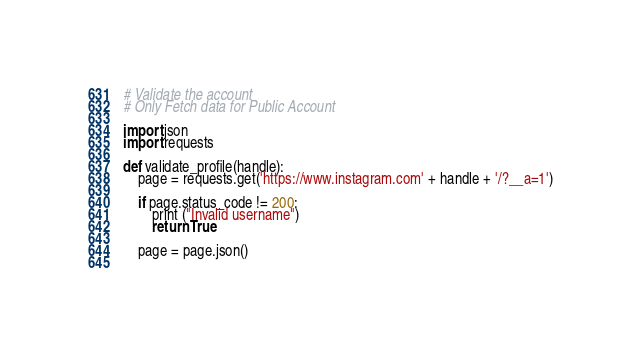<code> <loc_0><loc_0><loc_500><loc_500><_Python_># Validate the account
# Only Fetch data for Public Account

import json
import requests

def validate_profile(handle):
	page = requests.get('https://www.instagram.com' + handle + '/?__a=1')

	if page.status_code != 200:
		print ("Invalid username")
		return True

	page = page.json()
	</code> 